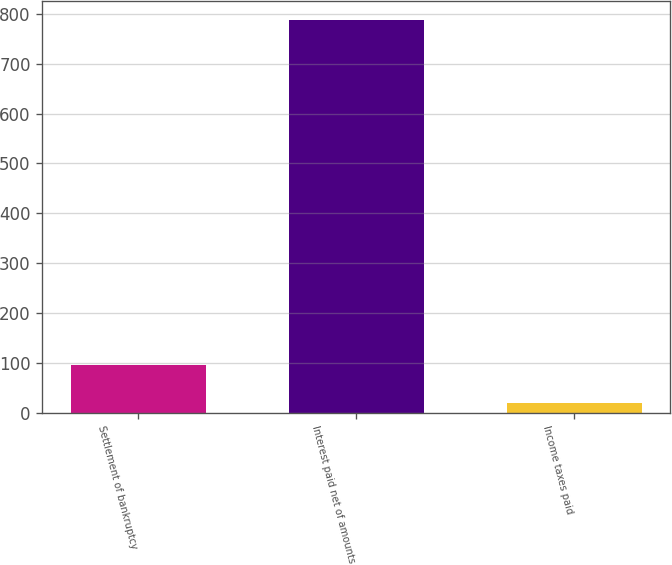<chart> <loc_0><loc_0><loc_500><loc_500><bar_chart><fcel>Settlement of bankruptcy<fcel>Interest paid net of amounts<fcel>Income taxes paid<nl><fcel>95.8<fcel>787<fcel>19<nl></chart> 